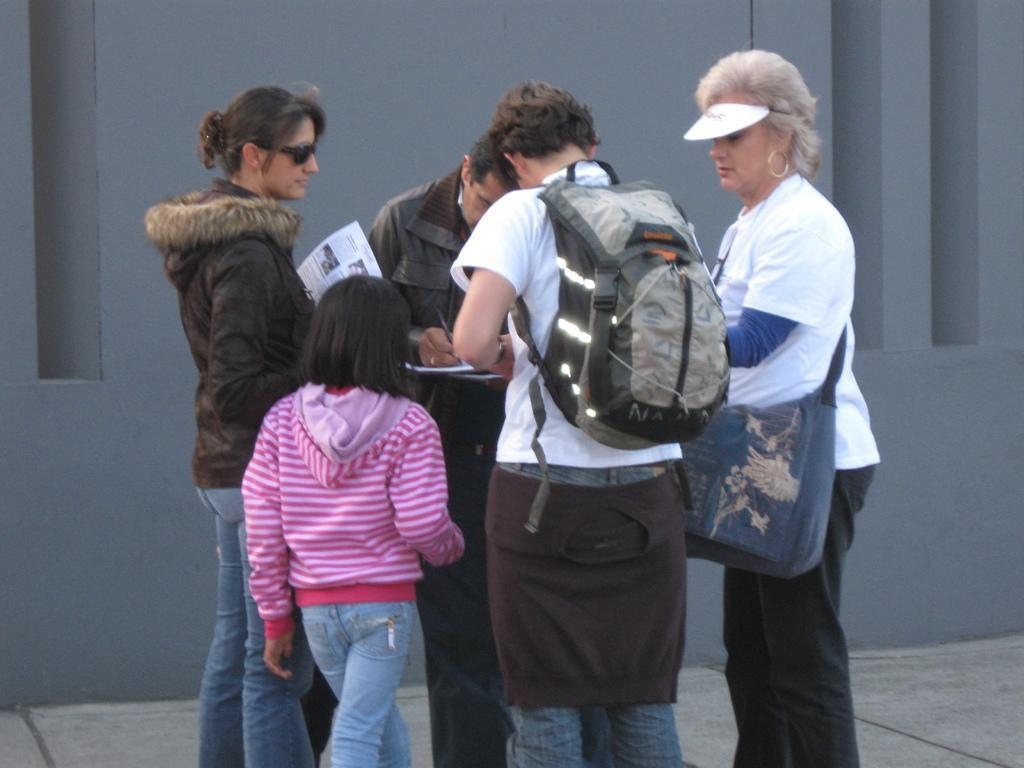How would you summarize this image in a sentence or two? In this image there are people standing. The man in the center is wearing a backpack next to him there is a lady, we can see girl beside him. In the background there is a wall. 